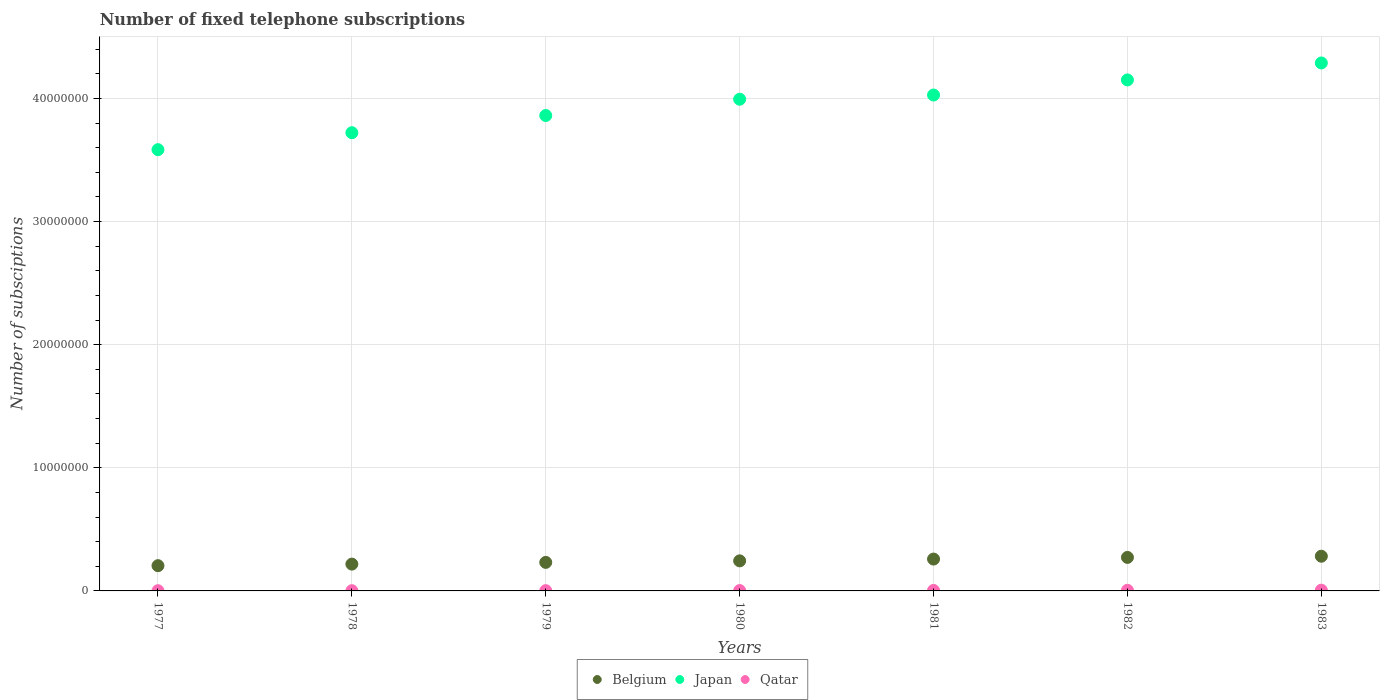How many different coloured dotlines are there?
Offer a very short reply. 3. What is the number of fixed telephone subscriptions in Qatar in 1983?
Give a very brief answer. 6.04e+04. Across all years, what is the maximum number of fixed telephone subscriptions in Qatar?
Offer a terse response. 6.04e+04. Across all years, what is the minimum number of fixed telephone subscriptions in Japan?
Offer a very short reply. 3.58e+07. In which year was the number of fixed telephone subscriptions in Japan maximum?
Offer a very short reply. 1983. In which year was the number of fixed telephone subscriptions in Belgium minimum?
Keep it short and to the point. 1977. What is the total number of fixed telephone subscriptions in Japan in the graph?
Provide a short and direct response. 2.76e+08. What is the difference between the number of fixed telephone subscriptions in Belgium in 1980 and that in 1983?
Provide a succinct answer. -3.76e+05. What is the difference between the number of fixed telephone subscriptions in Belgium in 1983 and the number of fixed telephone subscriptions in Qatar in 1980?
Give a very brief answer. 2.79e+06. What is the average number of fixed telephone subscriptions in Qatar per year?
Make the answer very short. 3.45e+04. In the year 1979, what is the difference between the number of fixed telephone subscriptions in Japan and number of fixed telephone subscriptions in Belgium?
Your answer should be very brief. 3.63e+07. In how many years, is the number of fixed telephone subscriptions in Qatar greater than 40000000?
Ensure brevity in your answer.  0. What is the ratio of the number of fixed telephone subscriptions in Qatar in 1977 to that in 1983?
Offer a terse response. 0.28. Is the number of fixed telephone subscriptions in Belgium in 1979 less than that in 1980?
Offer a very short reply. Yes. What is the difference between the highest and the second highest number of fixed telephone subscriptions in Belgium?
Offer a very short reply. 9.60e+04. What is the difference between the highest and the lowest number of fixed telephone subscriptions in Belgium?
Your answer should be compact. 7.68e+05. In how many years, is the number of fixed telephone subscriptions in Japan greater than the average number of fixed telephone subscriptions in Japan taken over all years?
Give a very brief answer. 4. Is the number of fixed telephone subscriptions in Japan strictly greater than the number of fixed telephone subscriptions in Qatar over the years?
Make the answer very short. Yes. How many years are there in the graph?
Keep it short and to the point. 7. What is the difference between two consecutive major ticks on the Y-axis?
Provide a succinct answer. 1.00e+07. Does the graph contain any zero values?
Offer a terse response. No. How many legend labels are there?
Keep it short and to the point. 3. What is the title of the graph?
Ensure brevity in your answer.  Number of fixed telephone subscriptions. What is the label or title of the X-axis?
Offer a very short reply. Years. What is the label or title of the Y-axis?
Offer a terse response. Number of subsciptions. What is the Number of subsciptions of Belgium in 1977?
Offer a very short reply. 2.05e+06. What is the Number of subsciptions in Japan in 1977?
Ensure brevity in your answer.  3.58e+07. What is the Number of subsciptions in Qatar in 1977?
Your response must be concise. 1.71e+04. What is the Number of subsciptions in Belgium in 1978?
Provide a succinct answer. 2.18e+06. What is the Number of subsciptions in Japan in 1978?
Keep it short and to the point. 3.72e+07. What is the Number of subsciptions in Qatar in 1978?
Provide a succinct answer. 1.81e+04. What is the Number of subsciptions of Belgium in 1979?
Offer a terse response. 2.32e+06. What is the Number of subsciptions of Japan in 1979?
Give a very brief answer. 3.86e+07. What is the Number of subsciptions of Qatar in 1979?
Make the answer very short. 2.20e+04. What is the Number of subsciptions of Belgium in 1980?
Ensure brevity in your answer.  2.44e+06. What is the Number of subsciptions of Japan in 1980?
Give a very brief answer. 3.99e+07. What is the Number of subsciptions of Qatar in 1980?
Provide a short and direct response. 3.06e+04. What is the Number of subsciptions in Belgium in 1981?
Your answer should be very brief. 2.59e+06. What is the Number of subsciptions of Japan in 1981?
Keep it short and to the point. 4.03e+07. What is the Number of subsciptions of Qatar in 1981?
Offer a very short reply. 4.12e+04. What is the Number of subsciptions in Belgium in 1982?
Provide a short and direct response. 2.72e+06. What is the Number of subsciptions in Japan in 1982?
Your answer should be compact. 4.15e+07. What is the Number of subsciptions in Qatar in 1982?
Keep it short and to the point. 5.19e+04. What is the Number of subsciptions of Belgium in 1983?
Your answer should be compact. 2.82e+06. What is the Number of subsciptions in Japan in 1983?
Make the answer very short. 4.29e+07. What is the Number of subsciptions in Qatar in 1983?
Offer a very short reply. 6.04e+04. Across all years, what is the maximum Number of subsciptions in Belgium?
Give a very brief answer. 2.82e+06. Across all years, what is the maximum Number of subsciptions of Japan?
Provide a short and direct response. 4.29e+07. Across all years, what is the maximum Number of subsciptions of Qatar?
Your answer should be compact. 6.04e+04. Across all years, what is the minimum Number of subsciptions of Belgium?
Your response must be concise. 2.05e+06. Across all years, what is the minimum Number of subsciptions of Japan?
Your answer should be very brief. 3.58e+07. Across all years, what is the minimum Number of subsciptions in Qatar?
Provide a short and direct response. 1.71e+04. What is the total Number of subsciptions in Belgium in the graph?
Provide a succinct answer. 1.71e+07. What is the total Number of subsciptions of Japan in the graph?
Provide a short and direct response. 2.76e+08. What is the total Number of subsciptions of Qatar in the graph?
Give a very brief answer. 2.41e+05. What is the difference between the Number of subsciptions of Belgium in 1977 and that in 1978?
Ensure brevity in your answer.  -1.28e+05. What is the difference between the Number of subsciptions in Japan in 1977 and that in 1978?
Your answer should be compact. -1.38e+06. What is the difference between the Number of subsciptions of Qatar in 1977 and that in 1978?
Keep it short and to the point. -1000. What is the difference between the Number of subsciptions of Belgium in 1977 and that in 1979?
Your answer should be very brief. -2.67e+05. What is the difference between the Number of subsciptions of Japan in 1977 and that in 1979?
Provide a short and direct response. -2.77e+06. What is the difference between the Number of subsciptions in Qatar in 1977 and that in 1979?
Your answer should be compact. -4900. What is the difference between the Number of subsciptions in Belgium in 1977 and that in 1980?
Offer a very short reply. -3.92e+05. What is the difference between the Number of subsciptions in Japan in 1977 and that in 1980?
Make the answer very short. -4.10e+06. What is the difference between the Number of subsciptions of Qatar in 1977 and that in 1980?
Provide a succinct answer. -1.35e+04. What is the difference between the Number of subsciptions in Belgium in 1977 and that in 1981?
Your response must be concise. -5.37e+05. What is the difference between the Number of subsciptions of Japan in 1977 and that in 1981?
Ensure brevity in your answer.  -4.44e+06. What is the difference between the Number of subsciptions of Qatar in 1977 and that in 1981?
Ensure brevity in your answer.  -2.41e+04. What is the difference between the Number of subsciptions in Belgium in 1977 and that in 1982?
Ensure brevity in your answer.  -6.72e+05. What is the difference between the Number of subsciptions of Japan in 1977 and that in 1982?
Give a very brief answer. -5.66e+06. What is the difference between the Number of subsciptions of Qatar in 1977 and that in 1982?
Offer a very short reply. -3.48e+04. What is the difference between the Number of subsciptions in Belgium in 1977 and that in 1983?
Your answer should be compact. -7.68e+05. What is the difference between the Number of subsciptions in Japan in 1977 and that in 1983?
Give a very brief answer. -7.04e+06. What is the difference between the Number of subsciptions of Qatar in 1977 and that in 1983?
Keep it short and to the point. -4.33e+04. What is the difference between the Number of subsciptions in Belgium in 1978 and that in 1979?
Make the answer very short. -1.39e+05. What is the difference between the Number of subsciptions in Japan in 1978 and that in 1979?
Keep it short and to the point. -1.40e+06. What is the difference between the Number of subsciptions of Qatar in 1978 and that in 1979?
Provide a succinct answer. -3900. What is the difference between the Number of subsciptions of Belgium in 1978 and that in 1980?
Your response must be concise. -2.64e+05. What is the difference between the Number of subsciptions of Japan in 1978 and that in 1980?
Give a very brief answer. -2.72e+06. What is the difference between the Number of subsciptions of Qatar in 1978 and that in 1980?
Your response must be concise. -1.25e+04. What is the difference between the Number of subsciptions in Belgium in 1978 and that in 1981?
Your response must be concise. -4.09e+05. What is the difference between the Number of subsciptions of Japan in 1978 and that in 1981?
Provide a succinct answer. -3.06e+06. What is the difference between the Number of subsciptions of Qatar in 1978 and that in 1981?
Your answer should be compact. -2.31e+04. What is the difference between the Number of subsciptions of Belgium in 1978 and that in 1982?
Provide a succinct answer. -5.44e+05. What is the difference between the Number of subsciptions in Japan in 1978 and that in 1982?
Provide a short and direct response. -4.29e+06. What is the difference between the Number of subsciptions of Qatar in 1978 and that in 1982?
Provide a short and direct response. -3.38e+04. What is the difference between the Number of subsciptions in Belgium in 1978 and that in 1983?
Make the answer very short. -6.40e+05. What is the difference between the Number of subsciptions of Japan in 1978 and that in 1983?
Ensure brevity in your answer.  -5.67e+06. What is the difference between the Number of subsciptions of Qatar in 1978 and that in 1983?
Keep it short and to the point. -4.23e+04. What is the difference between the Number of subsciptions of Belgium in 1979 and that in 1980?
Your answer should be very brief. -1.25e+05. What is the difference between the Number of subsciptions of Japan in 1979 and that in 1980?
Your answer should be compact. -1.32e+06. What is the difference between the Number of subsciptions of Qatar in 1979 and that in 1980?
Provide a short and direct response. -8600. What is the difference between the Number of subsciptions of Belgium in 1979 and that in 1981?
Provide a succinct answer. -2.70e+05. What is the difference between the Number of subsciptions in Japan in 1979 and that in 1981?
Offer a very short reply. -1.66e+06. What is the difference between the Number of subsciptions in Qatar in 1979 and that in 1981?
Provide a short and direct response. -1.92e+04. What is the difference between the Number of subsciptions of Belgium in 1979 and that in 1982?
Your response must be concise. -4.05e+05. What is the difference between the Number of subsciptions in Japan in 1979 and that in 1982?
Make the answer very short. -2.89e+06. What is the difference between the Number of subsciptions in Qatar in 1979 and that in 1982?
Your answer should be very brief. -2.99e+04. What is the difference between the Number of subsciptions of Belgium in 1979 and that in 1983?
Provide a short and direct response. -5.01e+05. What is the difference between the Number of subsciptions in Japan in 1979 and that in 1983?
Your answer should be compact. -4.27e+06. What is the difference between the Number of subsciptions in Qatar in 1979 and that in 1983?
Your answer should be compact. -3.84e+04. What is the difference between the Number of subsciptions in Belgium in 1980 and that in 1981?
Ensure brevity in your answer.  -1.45e+05. What is the difference between the Number of subsciptions in Japan in 1980 and that in 1981?
Provide a short and direct response. -3.42e+05. What is the difference between the Number of subsciptions of Qatar in 1980 and that in 1981?
Your answer should be very brief. -1.06e+04. What is the difference between the Number of subsciptions of Belgium in 1980 and that in 1982?
Give a very brief answer. -2.80e+05. What is the difference between the Number of subsciptions in Japan in 1980 and that in 1982?
Make the answer very short. -1.57e+06. What is the difference between the Number of subsciptions of Qatar in 1980 and that in 1982?
Keep it short and to the point. -2.13e+04. What is the difference between the Number of subsciptions in Belgium in 1980 and that in 1983?
Keep it short and to the point. -3.76e+05. What is the difference between the Number of subsciptions of Japan in 1980 and that in 1983?
Ensure brevity in your answer.  -2.95e+06. What is the difference between the Number of subsciptions in Qatar in 1980 and that in 1983?
Keep it short and to the point. -2.98e+04. What is the difference between the Number of subsciptions of Belgium in 1981 and that in 1982?
Provide a short and direct response. -1.35e+05. What is the difference between the Number of subsciptions in Japan in 1981 and that in 1982?
Give a very brief answer. -1.23e+06. What is the difference between the Number of subsciptions of Qatar in 1981 and that in 1982?
Make the answer very short. -1.07e+04. What is the difference between the Number of subsciptions in Belgium in 1981 and that in 1983?
Ensure brevity in your answer.  -2.31e+05. What is the difference between the Number of subsciptions in Japan in 1981 and that in 1983?
Give a very brief answer. -2.60e+06. What is the difference between the Number of subsciptions in Qatar in 1981 and that in 1983?
Give a very brief answer. -1.92e+04. What is the difference between the Number of subsciptions in Belgium in 1982 and that in 1983?
Provide a short and direct response. -9.60e+04. What is the difference between the Number of subsciptions in Japan in 1982 and that in 1983?
Your response must be concise. -1.38e+06. What is the difference between the Number of subsciptions of Qatar in 1982 and that in 1983?
Offer a very short reply. -8482. What is the difference between the Number of subsciptions in Belgium in 1977 and the Number of subsciptions in Japan in 1978?
Offer a very short reply. -3.52e+07. What is the difference between the Number of subsciptions in Belgium in 1977 and the Number of subsciptions in Qatar in 1978?
Ensure brevity in your answer.  2.03e+06. What is the difference between the Number of subsciptions in Japan in 1977 and the Number of subsciptions in Qatar in 1978?
Give a very brief answer. 3.58e+07. What is the difference between the Number of subsciptions in Belgium in 1977 and the Number of subsciptions in Japan in 1979?
Offer a very short reply. -3.66e+07. What is the difference between the Number of subsciptions of Belgium in 1977 and the Number of subsciptions of Qatar in 1979?
Give a very brief answer. 2.03e+06. What is the difference between the Number of subsciptions in Japan in 1977 and the Number of subsciptions in Qatar in 1979?
Offer a terse response. 3.58e+07. What is the difference between the Number of subsciptions of Belgium in 1977 and the Number of subsciptions of Japan in 1980?
Offer a very short reply. -3.79e+07. What is the difference between the Number of subsciptions in Belgium in 1977 and the Number of subsciptions in Qatar in 1980?
Provide a short and direct response. 2.02e+06. What is the difference between the Number of subsciptions in Japan in 1977 and the Number of subsciptions in Qatar in 1980?
Give a very brief answer. 3.58e+07. What is the difference between the Number of subsciptions of Belgium in 1977 and the Number of subsciptions of Japan in 1981?
Give a very brief answer. -3.82e+07. What is the difference between the Number of subsciptions of Belgium in 1977 and the Number of subsciptions of Qatar in 1981?
Your response must be concise. 2.01e+06. What is the difference between the Number of subsciptions in Japan in 1977 and the Number of subsciptions in Qatar in 1981?
Offer a very short reply. 3.58e+07. What is the difference between the Number of subsciptions in Belgium in 1977 and the Number of subsciptions in Japan in 1982?
Your answer should be compact. -3.95e+07. What is the difference between the Number of subsciptions in Belgium in 1977 and the Number of subsciptions in Qatar in 1982?
Give a very brief answer. 2.00e+06. What is the difference between the Number of subsciptions in Japan in 1977 and the Number of subsciptions in Qatar in 1982?
Make the answer very short. 3.58e+07. What is the difference between the Number of subsciptions of Belgium in 1977 and the Number of subsciptions of Japan in 1983?
Keep it short and to the point. -4.08e+07. What is the difference between the Number of subsciptions in Belgium in 1977 and the Number of subsciptions in Qatar in 1983?
Your response must be concise. 1.99e+06. What is the difference between the Number of subsciptions in Japan in 1977 and the Number of subsciptions in Qatar in 1983?
Offer a terse response. 3.58e+07. What is the difference between the Number of subsciptions in Belgium in 1978 and the Number of subsciptions in Japan in 1979?
Provide a short and direct response. -3.64e+07. What is the difference between the Number of subsciptions of Belgium in 1978 and the Number of subsciptions of Qatar in 1979?
Keep it short and to the point. 2.16e+06. What is the difference between the Number of subsciptions of Japan in 1978 and the Number of subsciptions of Qatar in 1979?
Ensure brevity in your answer.  3.72e+07. What is the difference between the Number of subsciptions in Belgium in 1978 and the Number of subsciptions in Japan in 1980?
Make the answer very short. -3.78e+07. What is the difference between the Number of subsciptions of Belgium in 1978 and the Number of subsciptions of Qatar in 1980?
Your answer should be very brief. 2.15e+06. What is the difference between the Number of subsciptions in Japan in 1978 and the Number of subsciptions in Qatar in 1980?
Provide a succinct answer. 3.72e+07. What is the difference between the Number of subsciptions in Belgium in 1978 and the Number of subsciptions in Japan in 1981?
Ensure brevity in your answer.  -3.81e+07. What is the difference between the Number of subsciptions in Belgium in 1978 and the Number of subsciptions in Qatar in 1981?
Offer a terse response. 2.14e+06. What is the difference between the Number of subsciptions in Japan in 1978 and the Number of subsciptions in Qatar in 1981?
Provide a succinct answer. 3.72e+07. What is the difference between the Number of subsciptions of Belgium in 1978 and the Number of subsciptions of Japan in 1982?
Your answer should be very brief. -3.93e+07. What is the difference between the Number of subsciptions in Belgium in 1978 and the Number of subsciptions in Qatar in 1982?
Provide a short and direct response. 2.13e+06. What is the difference between the Number of subsciptions of Japan in 1978 and the Number of subsciptions of Qatar in 1982?
Keep it short and to the point. 3.72e+07. What is the difference between the Number of subsciptions of Belgium in 1978 and the Number of subsciptions of Japan in 1983?
Keep it short and to the point. -4.07e+07. What is the difference between the Number of subsciptions of Belgium in 1978 and the Number of subsciptions of Qatar in 1983?
Your response must be concise. 2.12e+06. What is the difference between the Number of subsciptions of Japan in 1978 and the Number of subsciptions of Qatar in 1983?
Give a very brief answer. 3.72e+07. What is the difference between the Number of subsciptions in Belgium in 1979 and the Number of subsciptions in Japan in 1980?
Your response must be concise. -3.76e+07. What is the difference between the Number of subsciptions in Belgium in 1979 and the Number of subsciptions in Qatar in 1980?
Offer a very short reply. 2.29e+06. What is the difference between the Number of subsciptions in Japan in 1979 and the Number of subsciptions in Qatar in 1980?
Your answer should be very brief. 3.86e+07. What is the difference between the Number of subsciptions of Belgium in 1979 and the Number of subsciptions of Japan in 1981?
Make the answer very short. -3.80e+07. What is the difference between the Number of subsciptions in Belgium in 1979 and the Number of subsciptions in Qatar in 1981?
Give a very brief answer. 2.28e+06. What is the difference between the Number of subsciptions in Japan in 1979 and the Number of subsciptions in Qatar in 1981?
Give a very brief answer. 3.86e+07. What is the difference between the Number of subsciptions in Belgium in 1979 and the Number of subsciptions in Japan in 1982?
Give a very brief answer. -3.92e+07. What is the difference between the Number of subsciptions in Belgium in 1979 and the Number of subsciptions in Qatar in 1982?
Your answer should be very brief. 2.27e+06. What is the difference between the Number of subsciptions of Japan in 1979 and the Number of subsciptions of Qatar in 1982?
Your response must be concise. 3.86e+07. What is the difference between the Number of subsciptions of Belgium in 1979 and the Number of subsciptions of Japan in 1983?
Offer a terse response. -4.06e+07. What is the difference between the Number of subsciptions of Belgium in 1979 and the Number of subsciptions of Qatar in 1983?
Your answer should be compact. 2.26e+06. What is the difference between the Number of subsciptions of Japan in 1979 and the Number of subsciptions of Qatar in 1983?
Ensure brevity in your answer.  3.86e+07. What is the difference between the Number of subsciptions of Belgium in 1980 and the Number of subsciptions of Japan in 1981?
Your response must be concise. -3.78e+07. What is the difference between the Number of subsciptions in Belgium in 1980 and the Number of subsciptions in Qatar in 1981?
Make the answer very short. 2.40e+06. What is the difference between the Number of subsciptions of Japan in 1980 and the Number of subsciptions of Qatar in 1981?
Provide a short and direct response. 3.99e+07. What is the difference between the Number of subsciptions of Belgium in 1980 and the Number of subsciptions of Japan in 1982?
Make the answer very short. -3.91e+07. What is the difference between the Number of subsciptions in Belgium in 1980 and the Number of subsciptions in Qatar in 1982?
Provide a short and direct response. 2.39e+06. What is the difference between the Number of subsciptions of Japan in 1980 and the Number of subsciptions of Qatar in 1982?
Your answer should be very brief. 3.99e+07. What is the difference between the Number of subsciptions in Belgium in 1980 and the Number of subsciptions in Japan in 1983?
Your answer should be very brief. -4.04e+07. What is the difference between the Number of subsciptions of Belgium in 1980 and the Number of subsciptions of Qatar in 1983?
Keep it short and to the point. 2.38e+06. What is the difference between the Number of subsciptions of Japan in 1980 and the Number of subsciptions of Qatar in 1983?
Offer a terse response. 3.99e+07. What is the difference between the Number of subsciptions of Belgium in 1981 and the Number of subsciptions of Japan in 1982?
Make the answer very short. -3.89e+07. What is the difference between the Number of subsciptions of Belgium in 1981 and the Number of subsciptions of Qatar in 1982?
Keep it short and to the point. 2.54e+06. What is the difference between the Number of subsciptions of Japan in 1981 and the Number of subsciptions of Qatar in 1982?
Ensure brevity in your answer.  4.02e+07. What is the difference between the Number of subsciptions of Belgium in 1981 and the Number of subsciptions of Japan in 1983?
Provide a succinct answer. -4.03e+07. What is the difference between the Number of subsciptions of Belgium in 1981 and the Number of subsciptions of Qatar in 1983?
Provide a short and direct response. 2.53e+06. What is the difference between the Number of subsciptions in Japan in 1981 and the Number of subsciptions in Qatar in 1983?
Your answer should be very brief. 4.02e+07. What is the difference between the Number of subsciptions of Belgium in 1982 and the Number of subsciptions of Japan in 1983?
Make the answer very short. -4.02e+07. What is the difference between the Number of subsciptions in Belgium in 1982 and the Number of subsciptions in Qatar in 1983?
Your answer should be very brief. 2.66e+06. What is the difference between the Number of subsciptions in Japan in 1982 and the Number of subsciptions in Qatar in 1983?
Provide a short and direct response. 4.14e+07. What is the average Number of subsciptions of Belgium per year?
Provide a succinct answer. 2.44e+06. What is the average Number of subsciptions of Japan per year?
Give a very brief answer. 3.95e+07. What is the average Number of subsciptions in Qatar per year?
Offer a very short reply. 3.45e+04. In the year 1977, what is the difference between the Number of subsciptions in Belgium and Number of subsciptions in Japan?
Provide a succinct answer. -3.38e+07. In the year 1977, what is the difference between the Number of subsciptions in Belgium and Number of subsciptions in Qatar?
Provide a short and direct response. 2.03e+06. In the year 1977, what is the difference between the Number of subsciptions in Japan and Number of subsciptions in Qatar?
Offer a very short reply. 3.58e+07. In the year 1978, what is the difference between the Number of subsciptions in Belgium and Number of subsciptions in Japan?
Give a very brief answer. -3.50e+07. In the year 1978, what is the difference between the Number of subsciptions in Belgium and Number of subsciptions in Qatar?
Keep it short and to the point. 2.16e+06. In the year 1978, what is the difference between the Number of subsciptions of Japan and Number of subsciptions of Qatar?
Offer a very short reply. 3.72e+07. In the year 1979, what is the difference between the Number of subsciptions in Belgium and Number of subsciptions in Japan?
Make the answer very short. -3.63e+07. In the year 1979, what is the difference between the Number of subsciptions of Belgium and Number of subsciptions of Qatar?
Your answer should be compact. 2.30e+06. In the year 1979, what is the difference between the Number of subsciptions in Japan and Number of subsciptions in Qatar?
Your response must be concise. 3.86e+07. In the year 1980, what is the difference between the Number of subsciptions of Belgium and Number of subsciptions of Japan?
Your answer should be compact. -3.75e+07. In the year 1980, what is the difference between the Number of subsciptions of Belgium and Number of subsciptions of Qatar?
Your response must be concise. 2.41e+06. In the year 1980, what is the difference between the Number of subsciptions of Japan and Number of subsciptions of Qatar?
Keep it short and to the point. 3.99e+07. In the year 1981, what is the difference between the Number of subsciptions of Belgium and Number of subsciptions of Japan?
Provide a succinct answer. -3.77e+07. In the year 1981, what is the difference between the Number of subsciptions in Belgium and Number of subsciptions in Qatar?
Make the answer very short. 2.55e+06. In the year 1981, what is the difference between the Number of subsciptions of Japan and Number of subsciptions of Qatar?
Your response must be concise. 4.02e+07. In the year 1982, what is the difference between the Number of subsciptions in Belgium and Number of subsciptions in Japan?
Offer a terse response. -3.88e+07. In the year 1982, what is the difference between the Number of subsciptions of Belgium and Number of subsciptions of Qatar?
Make the answer very short. 2.67e+06. In the year 1982, what is the difference between the Number of subsciptions of Japan and Number of subsciptions of Qatar?
Offer a very short reply. 4.14e+07. In the year 1983, what is the difference between the Number of subsciptions in Belgium and Number of subsciptions in Japan?
Give a very brief answer. -4.01e+07. In the year 1983, what is the difference between the Number of subsciptions in Belgium and Number of subsciptions in Qatar?
Keep it short and to the point. 2.76e+06. In the year 1983, what is the difference between the Number of subsciptions in Japan and Number of subsciptions in Qatar?
Provide a short and direct response. 4.28e+07. What is the ratio of the Number of subsciptions of Qatar in 1977 to that in 1978?
Provide a succinct answer. 0.94. What is the ratio of the Number of subsciptions in Belgium in 1977 to that in 1979?
Offer a terse response. 0.88. What is the ratio of the Number of subsciptions of Japan in 1977 to that in 1979?
Keep it short and to the point. 0.93. What is the ratio of the Number of subsciptions in Qatar in 1977 to that in 1979?
Your answer should be compact. 0.78. What is the ratio of the Number of subsciptions in Belgium in 1977 to that in 1980?
Give a very brief answer. 0.84. What is the ratio of the Number of subsciptions in Japan in 1977 to that in 1980?
Your answer should be very brief. 0.9. What is the ratio of the Number of subsciptions in Qatar in 1977 to that in 1980?
Provide a succinct answer. 0.56. What is the ratio of the Number of subsciptions in Belgium in 1977 to that in 1981?
Your answer should be very brief. 0.79. What is the ratio of the Number of subsciptions of Japan in 1977 to that in 1981?
Offer a terse response. 0.89. What is the ratio of the Number of subsciptions of Qatar in 1977 to that in 1981?
Your answer should be compact. 0.41. What is the ratio of the Number of subsciptions in Belgium in 1977 to that in 1982?
Make the answer very short. 0.75. What is the ratio of the Number of subsciptions of Japan in 1977 to that in 1982?
Keep it short and to the point. 0.86. What is the ratio of the Number of subsciptions in Qatar in 1977 to that in 1982?
Your answer should be very brief. 0.33. What is the ratio of the Number of subsciptions of Belgium in 1977 to that in 1983?
Keep it short and to the point. 0.73. What is the ratio of the Number of subsciptions in Japan in 1977 to that in 1983?
Offer a terse response. 0.84. What is the ratio of the Number of subsciptions of Qatar in 1977 to that in 1983?
Ensure brevity in your answer.  0.28. What is the ratio of the Number of subsciptions in Belgium in 1978 to that in 1979?
Your answer should be compact. 0.94. What is the ratio of the Number of subsciptions of Japan in 1978 to that in 1979?
Give a very brief answer. 0.96. What is the ratio of the Number of subsciptions in Qatar in 1978 to that in 1979?
Offer a terse response. 0.82. What is the ratio of the Number of subsciptions in Belgium in 1978 to that in 1980?
Make the answer very short. 0.89. What is the ratio of the Number of subsciptions of Japan in 1978 to that in 1980?
Provide a succinct answer. 0.93. What is the ratio of the Number of subsciptions in Qatar in 1978 to that in 1980?
Offer a terse response. 0.59. What is the ratio of the Number of subsciptions of Belgium in 1978 to that in 1981?
Give a very brief answer. 0.84. What is the ratio of the Number of subsciptions in Japan in 1978 to that in 1981?
Provide a succinct answer. 0.92. What is the ratio of the Number of subsciptions in Qatar in 1978 to that in 1981?
Keep it short and to the point. 0.44. What is the ratio of the Number of subsciptions in Belgium in 1978 to that in 1982?
Your answer should be compact. 0.8. What is the ratio of the Number of subsciptions in Japan in 1978 to that in 1982?
Ensure brevity in your answer.  0.9. What is the ratio of the Number of subsciptions of Qatar in 1978 to that in 1982?
Your answer should be compact. 0.35. What is the ratio of the Number of subsciptions in Belgium in 1978 to that in 1983?
Ensure brevity in your answer.  0.77. What is the ratio of the Number of subsciptions in Japan in 1978 to that in 1983?
Offer a very short reply. 0.87. What is the ratio of the Number of subsciptions in Qatar in 1978 to that in 1983?
Keep it short and to the point. 0.3. What is the ratio of the Number of subsciptions of Belgium in 1979 to that in 1980?
Give a very brief answer. 0.95. What is the ratio of the Number of subsciptions in Japan in 1979 to that in 1980?
Keep it short and to the point. 0.97. What is the ratio of the Number of subsciptions of Qatar in 1979 to that in 1980?
Give a very brief answer. 0.72. What is the ratio of the Number of subsciptions of Belgium in 1979 to that in 1981?
Offer a very short reply. 0.9. What is the ratio of the Number of subsciptions of Japan in 1979 to that in 1981?
Keep it short and to the point. 0.96. What is the ratio of the Number of subsciptions in Qatar in 1979 to that in 1981?
Give a very brief answer. 0.53. What is the ratio of the Number of subsciptions in Belgium in 1979 to that in 1982?
Your answer should be very brief. 0.85. What is the ratio of the Number of subsciptions of Japan in 1979 to that in 1982?
Offer a terse response. 0.93. What is the ratio of the Number of subsciptions in Qatar in 1979 to that in 1982?
Your answer should be very brief. 0.42. What is the ratio of the Number of subsciptions in Belgium in 1979 to that in 1983?
Make the answer very short. 0.82. What is the ratio of the Number of subsciptions of Japan in 1979 to that in 1983?
Make the answer very short. 0.9. What is the ratio of the Number of subsciptions of Qatar in 1979 to that in 1983?
Your response must be concise. 0.36. What is the ratio of the Number of subsciptions in Belgium in 1980 to that in 1981?
Make the answer very short. 0.94. What is the ratio of the Number of subsciptions of Qatar in 1980 to that in 1981?
Give a very brief answer. 0.74. What is the ratio of the Number of subsciptions in Belgium in 1980 to that in 1982?
Your answer should be very brief. 0.9. What is the ratio of the Number of subsciptions in Japan in 1980 to that in 1982?
Offer a very short reply. 0.96. What is the ratio of the Number of subsciptions in Qatar in 1980 to that in 1982?
Provide a succinct answer. 0.59. What is the ratio of the Number of subsciptions of Belgium in 1980 to that in 1983?
Your answer should be very brief. 0.87. What is the ratio of the Number of subsciptions in Japan in 1980 to that in 1983?
Your answer should be compact. 0.93. What is the ratio of the Number of subsciptions of Qatar in 1980 to that in 1983?
Make the answer very short. 0.51. What is the ratio of the Number of subsciptions in Belgium in 1981 to that in 1982?
Make the answer very short. 0.95. What is the ratio of the Number of subsciptions in Japan in 1981 to that in 1982?
Provide a short and direct response. 0.97. What is the ratio of the Number of subsciptions of Qatar in 1981 to that in 1982?
Provide a succinct answer. 0.79. What is the ratio of the Number of subsciptions in Belgium in 1981 to that in 1983?
Offer a very short reply. 0.92. What is the ratio of the Number of subsciptions of Japan in 1981 to that in 1983?
Provide a succinct answer. 0.94. What is the ratio of the Number of subsciptions of Qatar in 1981 to that in 1983?
Your response must be concise. 0.68. What is the ratio of the Number of subsciptions of Belgium in 1982 to that in 1983?
Your answer should be compact. 0.97. What is the ratio of the Number of subsciptions of Japan in 1982 to that in 1983?
Keep it short and to the point. 0.97. What is the ratio of the Number of subsciptions in Qatar in 1982 to that in 1983?
Your response must be concise. 0.86. What is the difference between the highest and the second highest Number of subsciptions of Belgium?
Your answer should be very brief. 9.60e+04. What is the difference between the highest and the second highest Number of subsciptions in Japan?
Give a very brief answer. 1.38e+06. What is the difference between the highest and the second highest Number of subsciptions in Qatar?
Provide a succinct answer. 8482. What is the difference between the highest and the lowest Number of subsciptions of Belgium?
Keep it short and to the point. 7.68e+05. What is the difference between the highest and the lowest Number of subsciptions of Japan?
Offer a very short reply. 7.04e+06. What is the difference between the highest and the lowest Number of subsciptions in Qatar?
Offer a very short reply. 4.33e+04. 